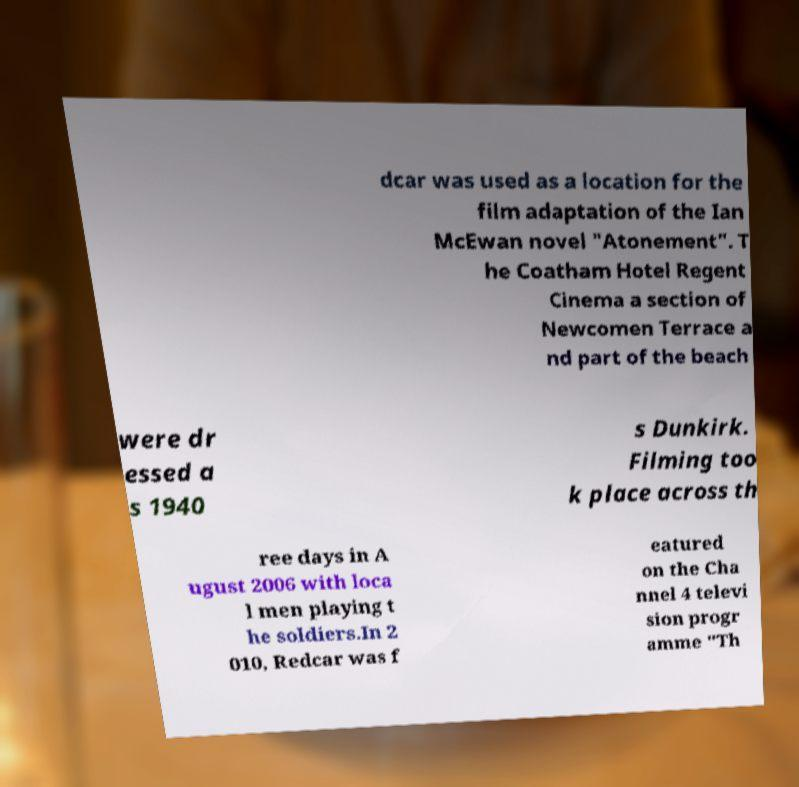Could you assist in decoding the text presented in this image and type it out clearly? dcar was used as a location for the film adaptation of the Ian McEwan novel "Atonement". T he Coatham Hotel Regent Cinema a section of Newcomen Terrace a nd part of the beach were dr essed a s 1940 s Dunkirk. Filming too k place across th ree days in A ugust 2006 with loca l men playing t he soldiers.In 2 010, Redcar was f eatured on the Cha nnel 4 televi sion progr amme "Th 